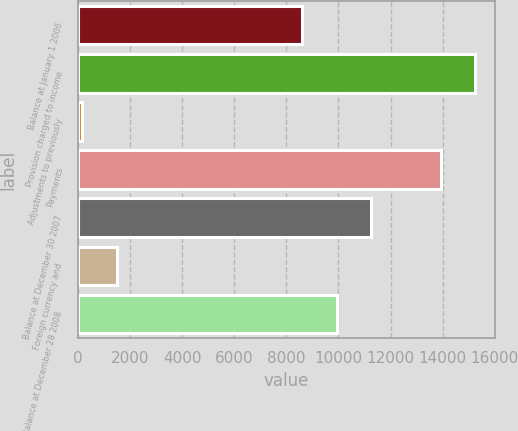Convert chart. <chart><loc_0><loc_0><loc_500><loc_500><bar_chart><fcel>Balance at January 1 2006<fcel>Provision charged to income<fcel>Adjustments to previously<fcel>Payments<fcel>Balance at December 30 2007<fcel>Foreign currency and<fcel>Balance at December 28 2008<nl><fcel>8610<fcel>15250.5<fcel>158<fcel>13922.4<fcel>11266.2<fcel>1486.1<fcel>9938.1<nl></chart> 